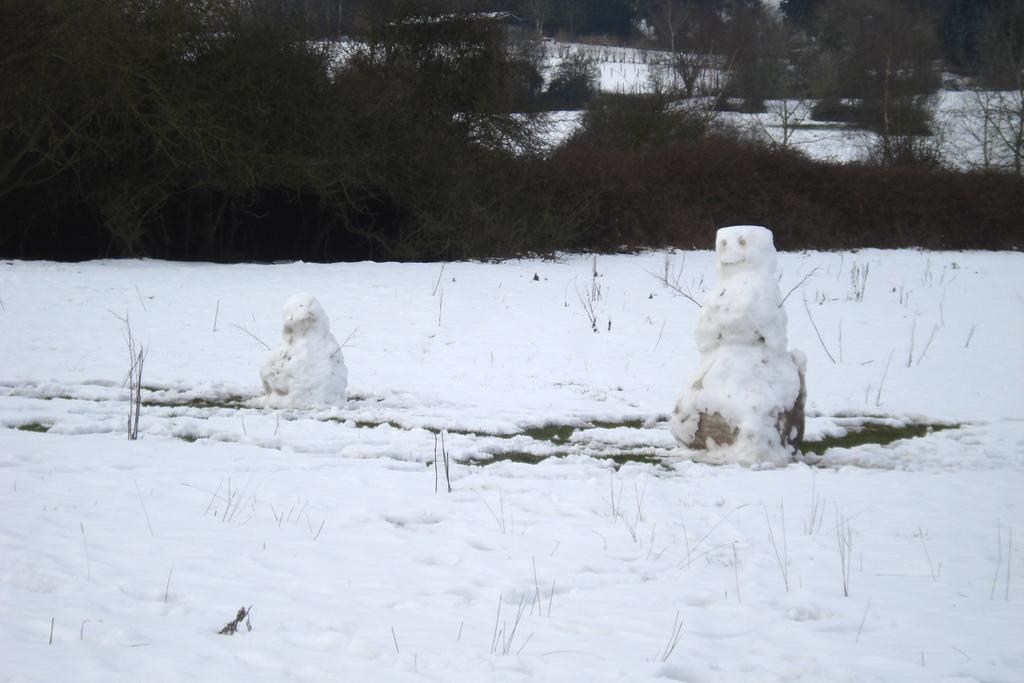Please provide a concise description of this image. In this picture we can see snow at the bottom, there are two snow dolls in the middle, in the background we can see trees. 